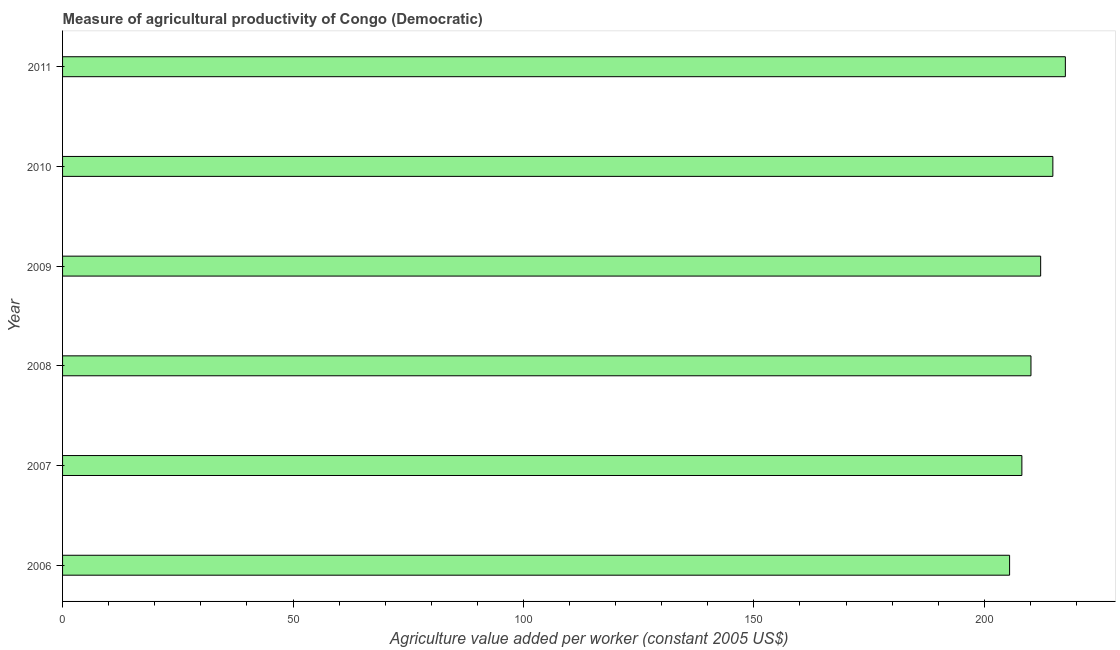Does the graph contain grids?
Ensure brevity in your answer.  No. What is the title of the graph?
Keep it short and to the point. Measure of agricultural productivity of Congo (Democratic). What is the label or title of the X-axis?
Your answer should be compact. Agriculture value added per worker (constant 2005 US$). What is the label or title of the Y-axis?
Make the answer very short. Year. What is the agriculture value added per worker in 2008?
Make the answer very short. 210.12. Across all years, what is the maximum agriculture value added per worker?
Offer a very short reply. 217.58. Across all years, what is the minimum agriculture value added per worker?
Keep it short and to the point. 205.48. What is the sum of the agriculture value added per worker?
Keep it short and to the point. 1268.41. What is the difference between the agriculture value added per worker in 2008 and 2009?
Give a very brief answer. -2.1. What is the average agriculture value added per worker per year?
Provide a short and direct response. 211.4. What is the median agriculture value added per worker?
Ensure brevity in your answer.  211.17. In how many years, is the agriculture value added per worker greater than 140 US$?
Keep it short and to the point. 6. Is the agriculture value added per worker in 2008 less than that in 2011?
Your answer should be compact. Yes. What is the difference between the highest and the second highest agriculture value added per worker?
Give a very brief answer. 2.71. What is the difference between the highest and the lowest agriculture value added per worker?
Ensure brevity in your answer.  12.1. In how many years, is the agriculture value added per worker greater than the average agriculture value added per worker taken over all years?
Offer a terse response. 3. How many bars are there?
Your answer should be very brief. 6. Are all the bars in the graph horizontal?
Offer a very short reply. Yes. How many years are there in the graph?
Provide a succinct answer. 6. What is the Agriculture value added per worker (constant 2005 US$) in 2006?
Give a very brief answer. 205.48. What is the Agriculture value added per worker (constant 2005 US$) in 2007?
Offer a very short reply. 208.14. What is the Agriculture value added per worker (constant 2005 US$) of 2008?
Your response must be concise. 210.12. What is the Agriculture value added per worker (constant 2005 US$) of 2009?
Offer a very short reply. 212.22. What is the Agriculture value added per worker (constant 2005 US$) of 2010?
Provide a succinct answer. 214.87. What is the Agriculture value added per worker (constant 2005 US$) in 2011?
Your answer should be compact. 217.58. What is the difference between the Agriculture value added per worker (constant 2005 US$) in 2006 and 2007?
Your response must be concise. -2.66. What is the difference between the Agriculture value added per worker (constant 2005 US$) in 2006 and 2008?
Ensure brevity in your answer.  -4.64. What is the difference between the Agriculture value added per worker (constant 2005 US$) in 2006 and 2009?
Your response must be concise. -6.74. What is the difference between the Agriculture value added per worker (constant 2005 US$) in 2006 and 2010?
Ensure brevity in your answer.  -9.39. What is the difference between the Agriculture value added per worker (constant 2005 US$) in 2006 and 2011?
Offer a terse response. -12.1. What is the difference between the Agriculture value added per worker (constant 2005 US$) in 2007 and 2008?
Make the answer very short. -1.97. What is the difference between the Agriculture value added per worker (constant 2005 US$) in 2007 and 2009?
Your response must be concise. -4.08. What is the difference between the Agriculture value added per worker (constant 2005 US$) in 2007 and 2010?
Your answer should be very brief. -6.72. What is the difference between the Agriculture value added per worker (constant 2005 US$) in 2007 and 2011?
Keep it short and to the point. -9.43. What is the difference between the Agriculture value added per worker (constant 2005 US$) in 2008 and 2009?
Offer a terse response. -2.1. What is the difference between the Agriculture value added per worker (constant 2005 US$) in 2008 and 2010?
Your answer should be compact. -4.75. What is the difference between the Agriculture value added per worker (constant 2005 US$) in 2008 and 2011?
Ensure brevity in your answer.  -7.46. What is the difference between the Agriculture value added per worker (constant 2005 US$) in 2009 and 2010?
Your answer should be compact. -2.65. What is the difference between the Agriculture value added per worker (constant 2005 US$) in 2009 and 2011?
Keep it short and to the point. -5.36. What is the difference between the Agriculture value added per worker (constant 2005 US$) in 2010 and 2011?
Provide a succinct answer. -2.71. What is the ratio of the Agriculture value added per worker (constant 2005 US$) in 2006 to that in 2007?
Offer a terse response. 0.99. What is the ratio of the Agriculture value added per worker (constant 2005 US$) in 2006 to that in 2009?
Keep it short and to the point. 0.97. What is the ratio of the Agriculture value added per worker (constant 2005 US$) in 2006 to that in 2010?
Ensure brevity in your answer.  0.96. What is the ratio of the Agriculture value added per worker (constant 2005 US$) in 2006 to that in 2011?
Ensure brevity in your answer.  0.94. What is the ratio of the Agriculture value added per worker (constant 2005 US$) in 2007 to that in 2008?
Ensure brevity in your answer.  0.99. What is the ratio of the Agriculture value added per worker (constant 2005 US$) in 2007 to that in 2010?
Your response must be concise. 0.97. What is the ratio of the Agriculture value added per worker (constant 2005 US$) in 2008 to that in 2010?
Your answer should be compact. 0.98. What is the ratio of the Agriculture value added per worker (constant 2005 US$) in 2009 to that in 2010?
Your answer should be very brief. 0.99. What is the ratio of the Agriculture value added per worker (constant 2005 US$) in 2010 to that in 2011?
Offer a very short reply. 0.99. 